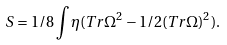Convert formula to latex. <formula><loc_0><loc_0><loc_500><loc_500>S = 1 / 8 \int { \eta } ( T r { \Omega } ^ { 2 } - 1 / 2 ( T r { \Omega } ) ^ { 2 } ) .</formula> 